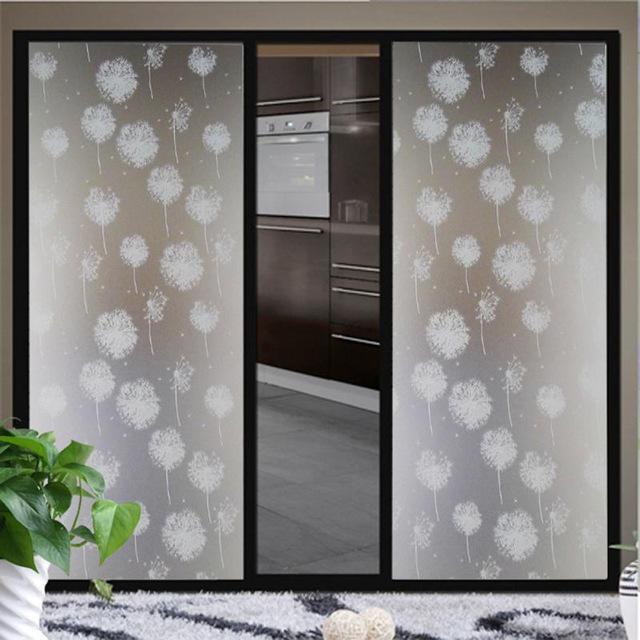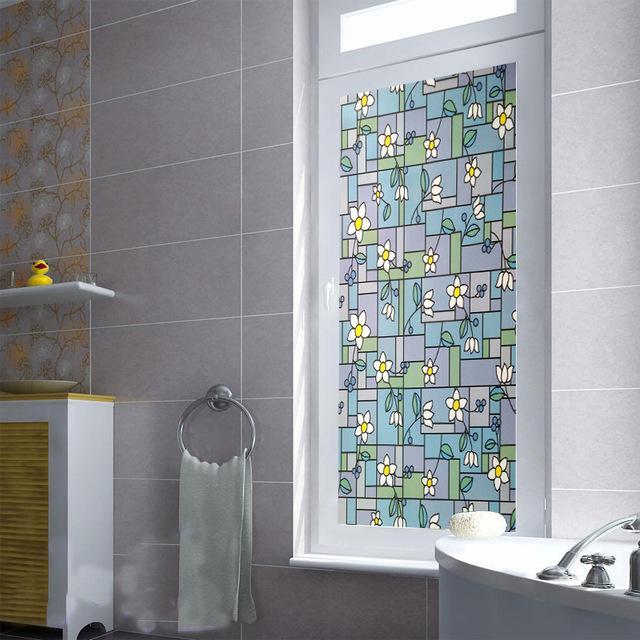The first image is the image on the left, the second image is the image on the right. Given the left and right images, does the statement "Both images contain an object with a plant design on it." hold true? Answer yes or no. Yes. The first image is the image on the left, the second image is the image on the right. For the images displayed, is the sentence "An image shows a black framed sliding door unit with a narrower middle mirrored section, behind a plush rug and a potted plant." factually correct? Answer yes or no. Yes. 